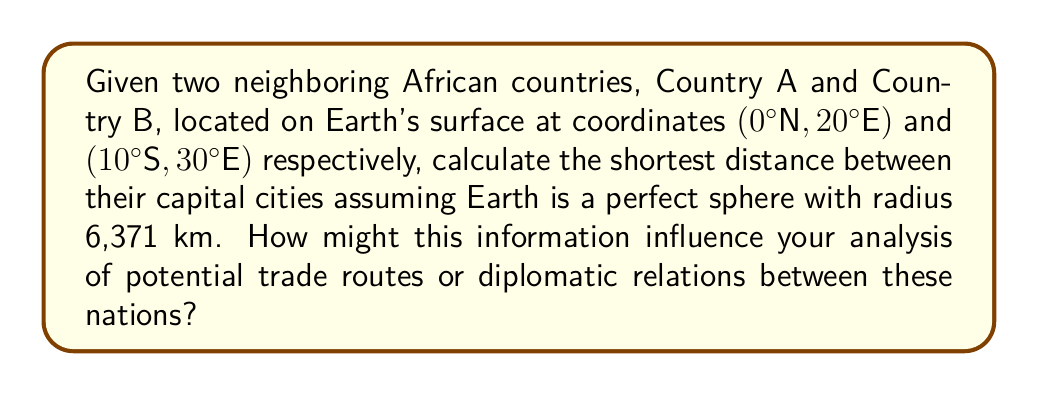Show me your answer to this math problem. To solve this problem, we'll use the great circle distance formula, which calculates the shortest path between two points on a sphere. The steps are as follows:

1. Convert the coordinates to radians:
   $\phi_1 = 0° = 0$ rad
   $\lambda_1 = 20° = \frac{20\pi}{180}$ rad
   $\phi_2 = -10° = -\frac{10\pi}{180}$ rad (negative because it's South)
   $\lambda_2 = 30° = \frac{30\pi}{180}$ rad

2. Apply the great circle distance formula:
   $$d = R \cdot \arccos(\sin\phi_1 \sin\phi_2 + \cos\phi_1 \cos\phi_2 \cos(\lambda_2 - \lambda_1))$$

   Where:
   $R$ is the Earth's radius (6,371 km)
   $\phi_1, \phi_2$ are latitudes in radians
   $\lambda_1, \lambda_2$ are longitudes in radians

3. Substitute the values:
   $$d = 6371 \cdot \arccos(\sin(0) \sin(-\frac{10\pi}{180}) + \cos(0) \cos(-\frac{10\pi}{180}) \cos(\frac{30\pi}{180} - \frac{20\pi}{180}))$$

4. Simplify:
   $$d = 6371 \cdot \arccos(0 + \cos(-\frac{10\pi}{180}) \cos(\frac{10\pi}{180}))$$
   $$d = 6371 \cdot \arccos(0.9848 \cdot 0.9848)$$
   $$d = 6371 \cdot \arccos(0.9698)$$
   $$d = 6371 \cdot 0.2456$$
   $$d \approx 1564.7 \text{ km}$$

This distance represents the shortest path between the two capital cities on the Earth's surface, which could influence trade routes and diplomatic relations by affecting transportation costs and travel times.
Answer: 1564.7 km 